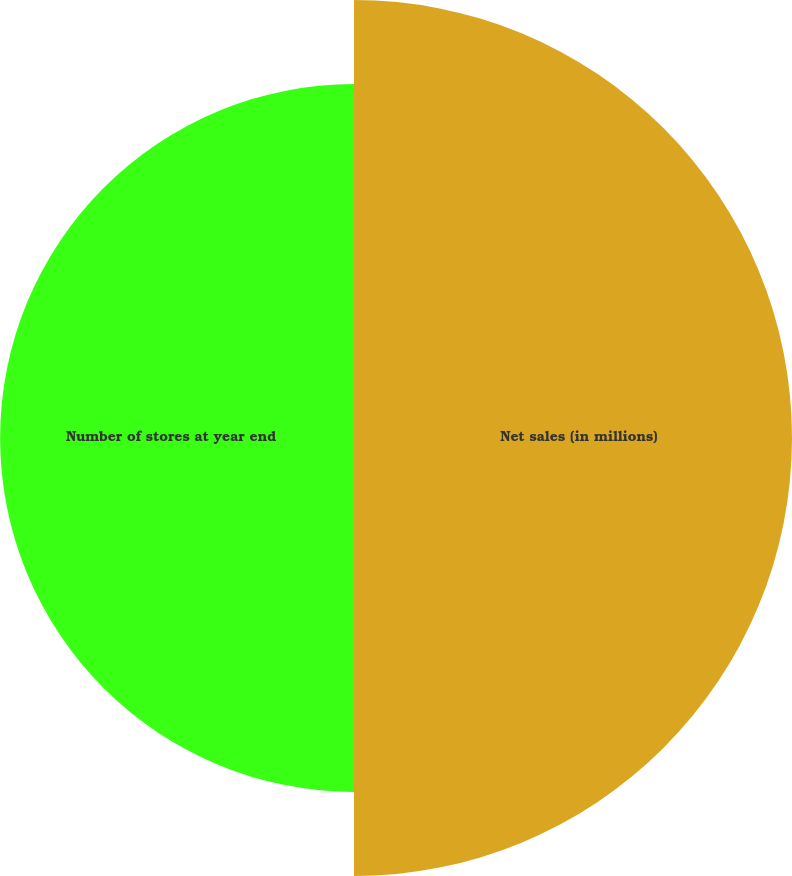Convert chart. <chart><loc_0><loc_0><loc_500><loc_500><pie_chart><fcel>Net sales (in millions)<fcel>Number of stores at year end<nl><fcel>55.31%<fcel>44.69%<nl></chart> 